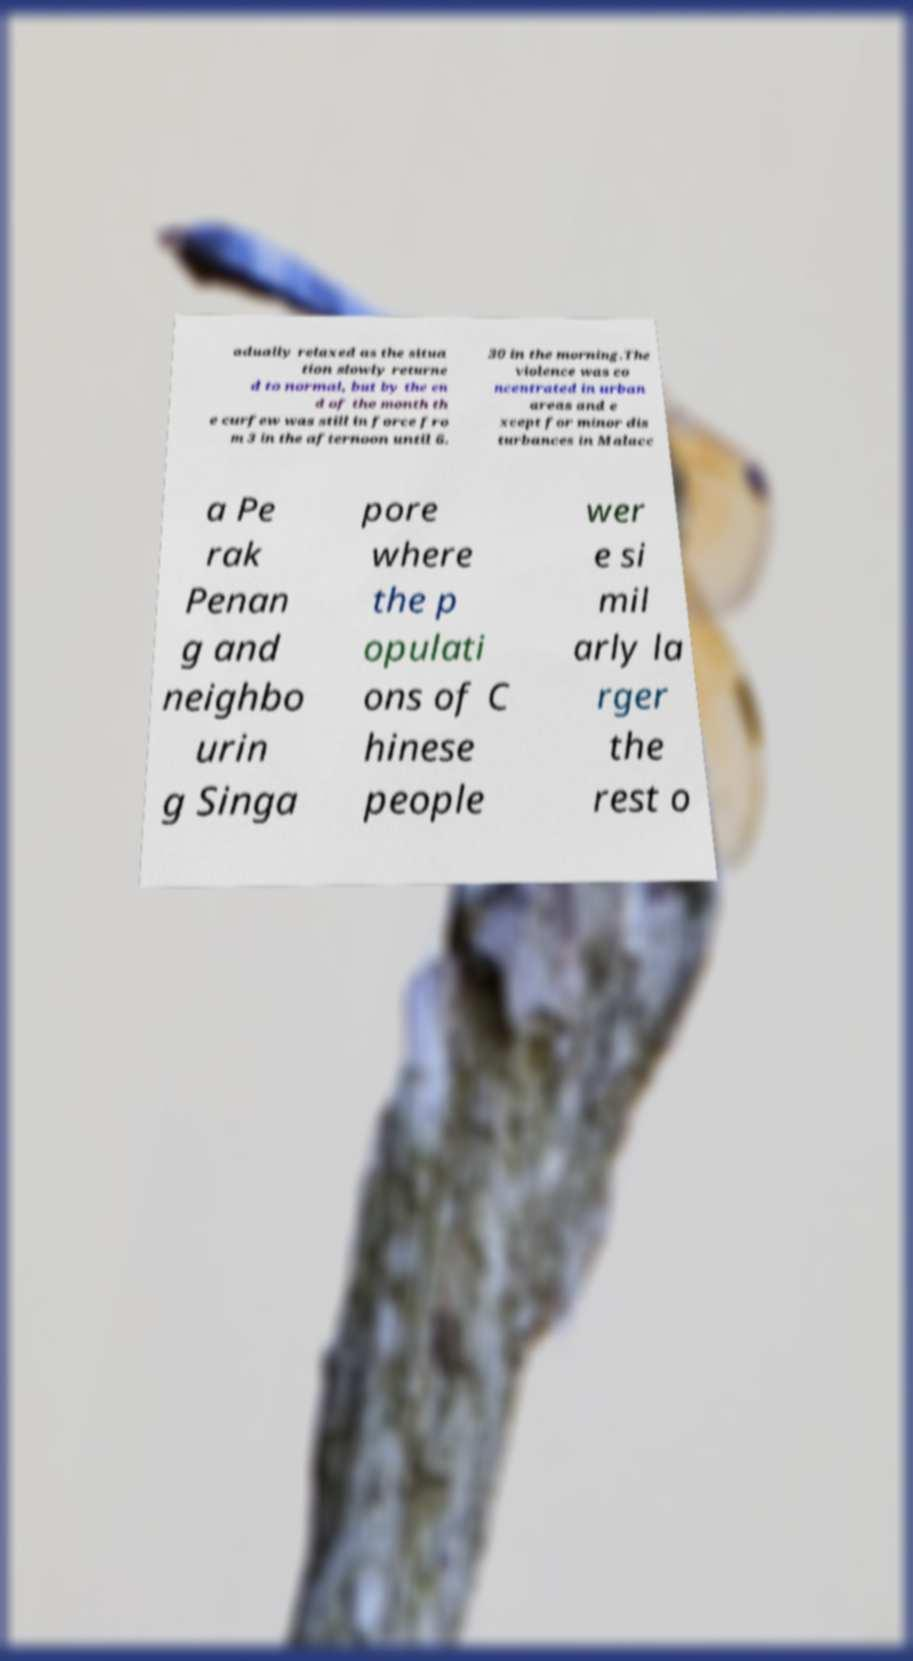I need the written content from this picture converted into text. Can you do that? adually relaxed as the situa tion slowly returne d to normal, but by the en d of the month th e curfew was still in force fro m 3 in the afternoon until 6. 30 in the morning.The violence was co ncentrated in urban areas and e xcept for minor dis turbances in Malacc a Pe rak Penan g and neighbo urin g Singa pore where the p opulati ons of C hinese people wer e si mil arly la rger the rest o 